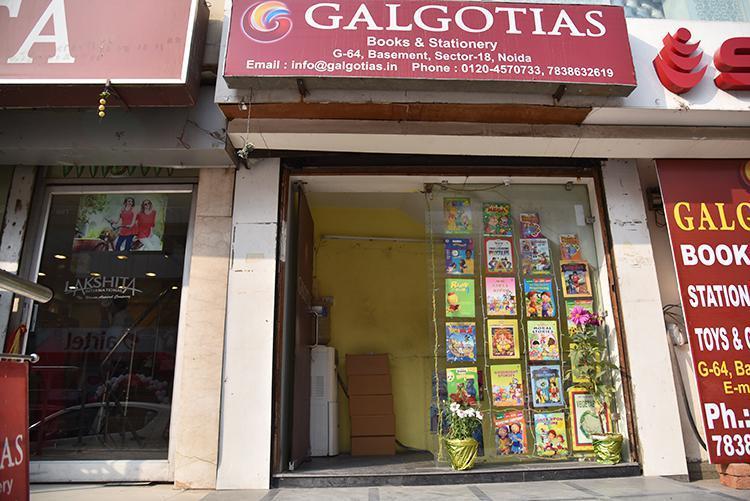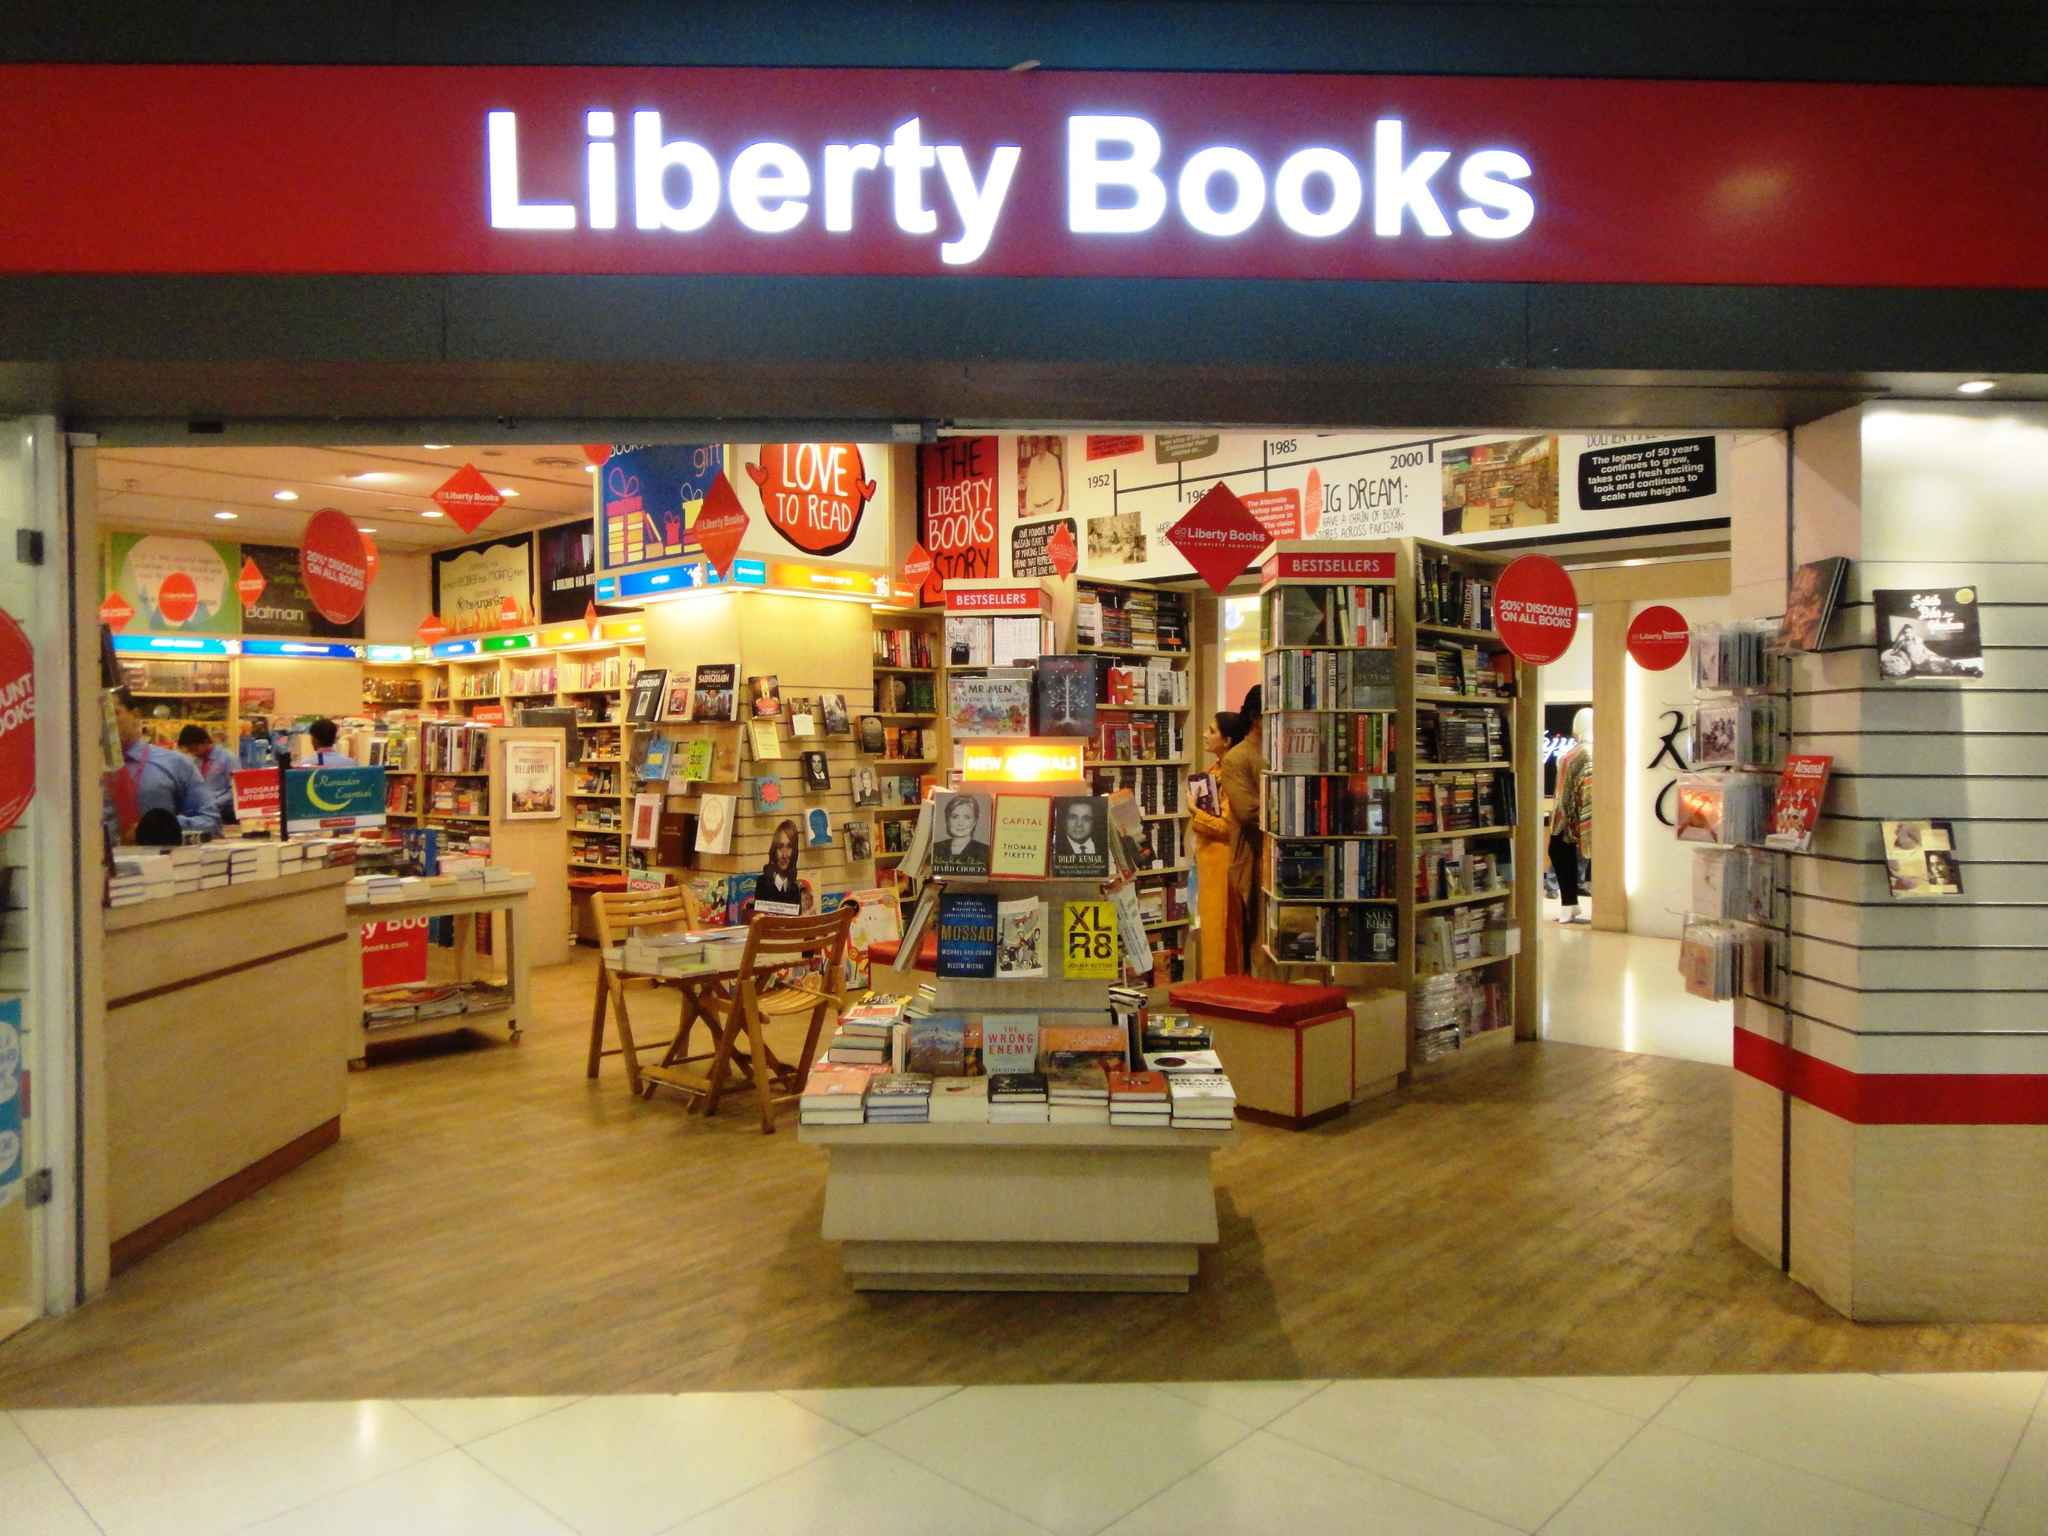The first image is the image on the left, the second image is the image on the right. Evaluate the accuracy of this statement regarding the images: "Both images show store exteriors with red-background signs above the entrance.". Is it true? Answer yes or no. Yes. The first image is the image on the left, the second image is the image on the right. Analyze the images presented: Is the assertion "In one image, a clerk can be seen to the left behind a counter of a bookstore, bookshelves extending down that wall and across the back, with three customers in the store." valid? Answer yes or no. No. 